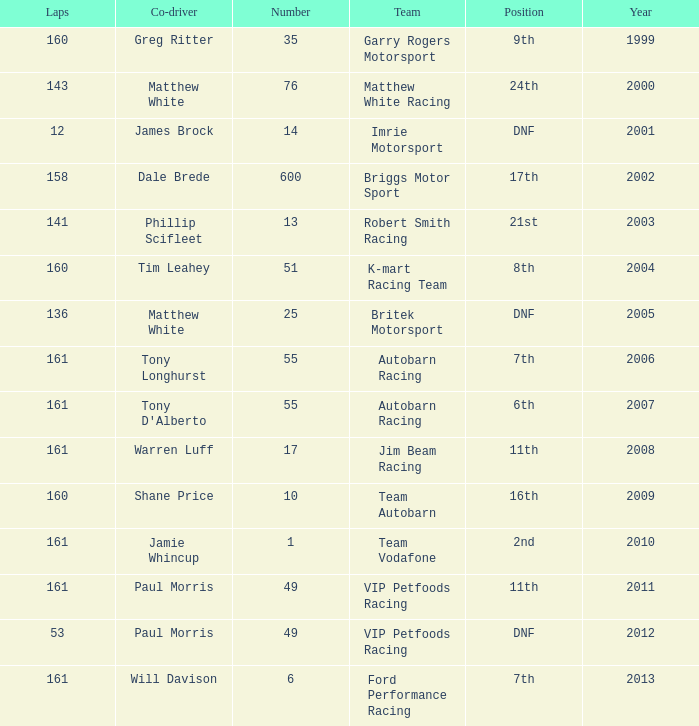What is the fewest laps for a team with a position of DNF and a number smaller than 25 before 2001? None. 